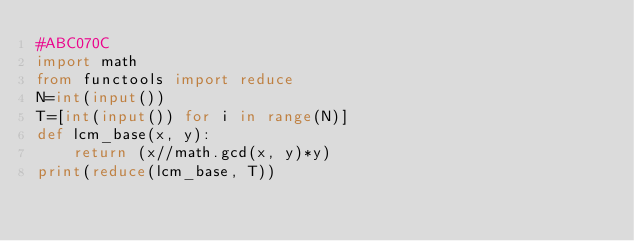<code> <loc_0><loc_0><loc_500><loc_500><_Python_>#ABC070C
import math
from functools import reduce
N=int(input())
T=[int(input()) for i in range(N)]
def lcm_base(x, y):
    return (x//math.gcd(x, y)*y)
print(reduce(lcm_base, T))
</code> 